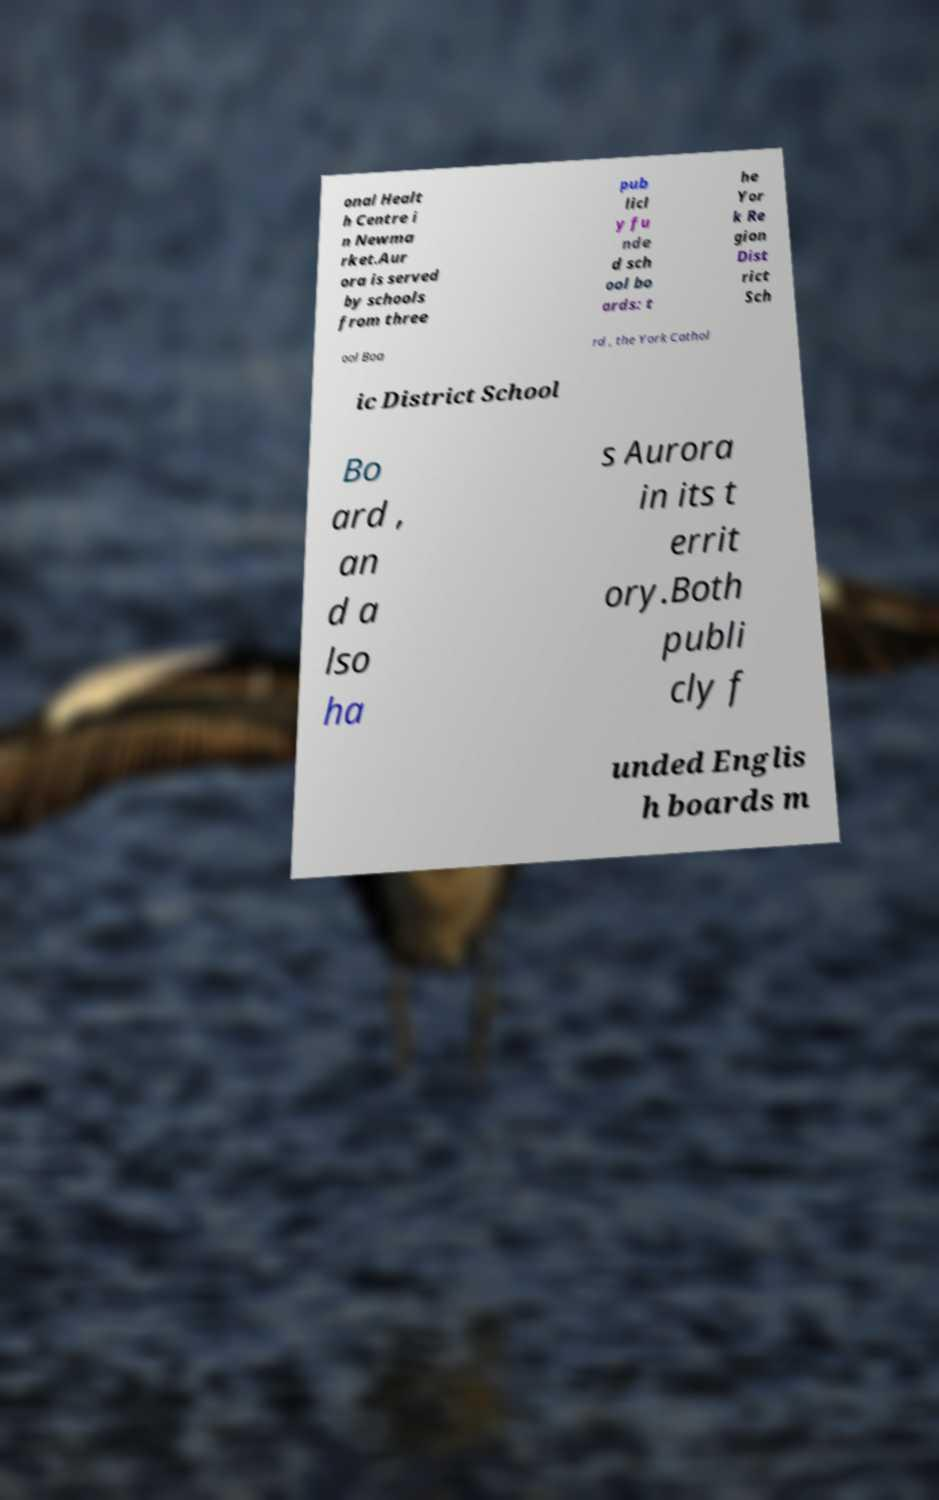Please identify and transcribe the text found in this image. onal Healt h Centre i n Newma rket.Aur ora is served by schools from three pub licl y fu nde d sch ool bo ards: t he Yor k Re gion Dist rict Sch ool Boa rd , the York Cathol ic District School Bo ard , an d a lso ha s Aurora in its t errit ory.Both publi cly f unded Englis h boards m 